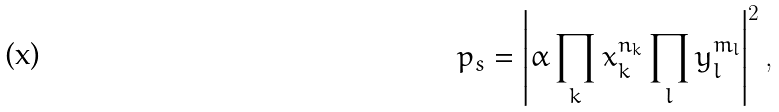<formula> <loc_0><loc_0><loc_500><loc_500>p _ { s } = \left | \alpha \prod _ { k } x _ { k } ^ { n _ { k } } \prod _ { l } y _ { l } ^ { m _ { l } } \right | ^ { 2 } ,</formula> 